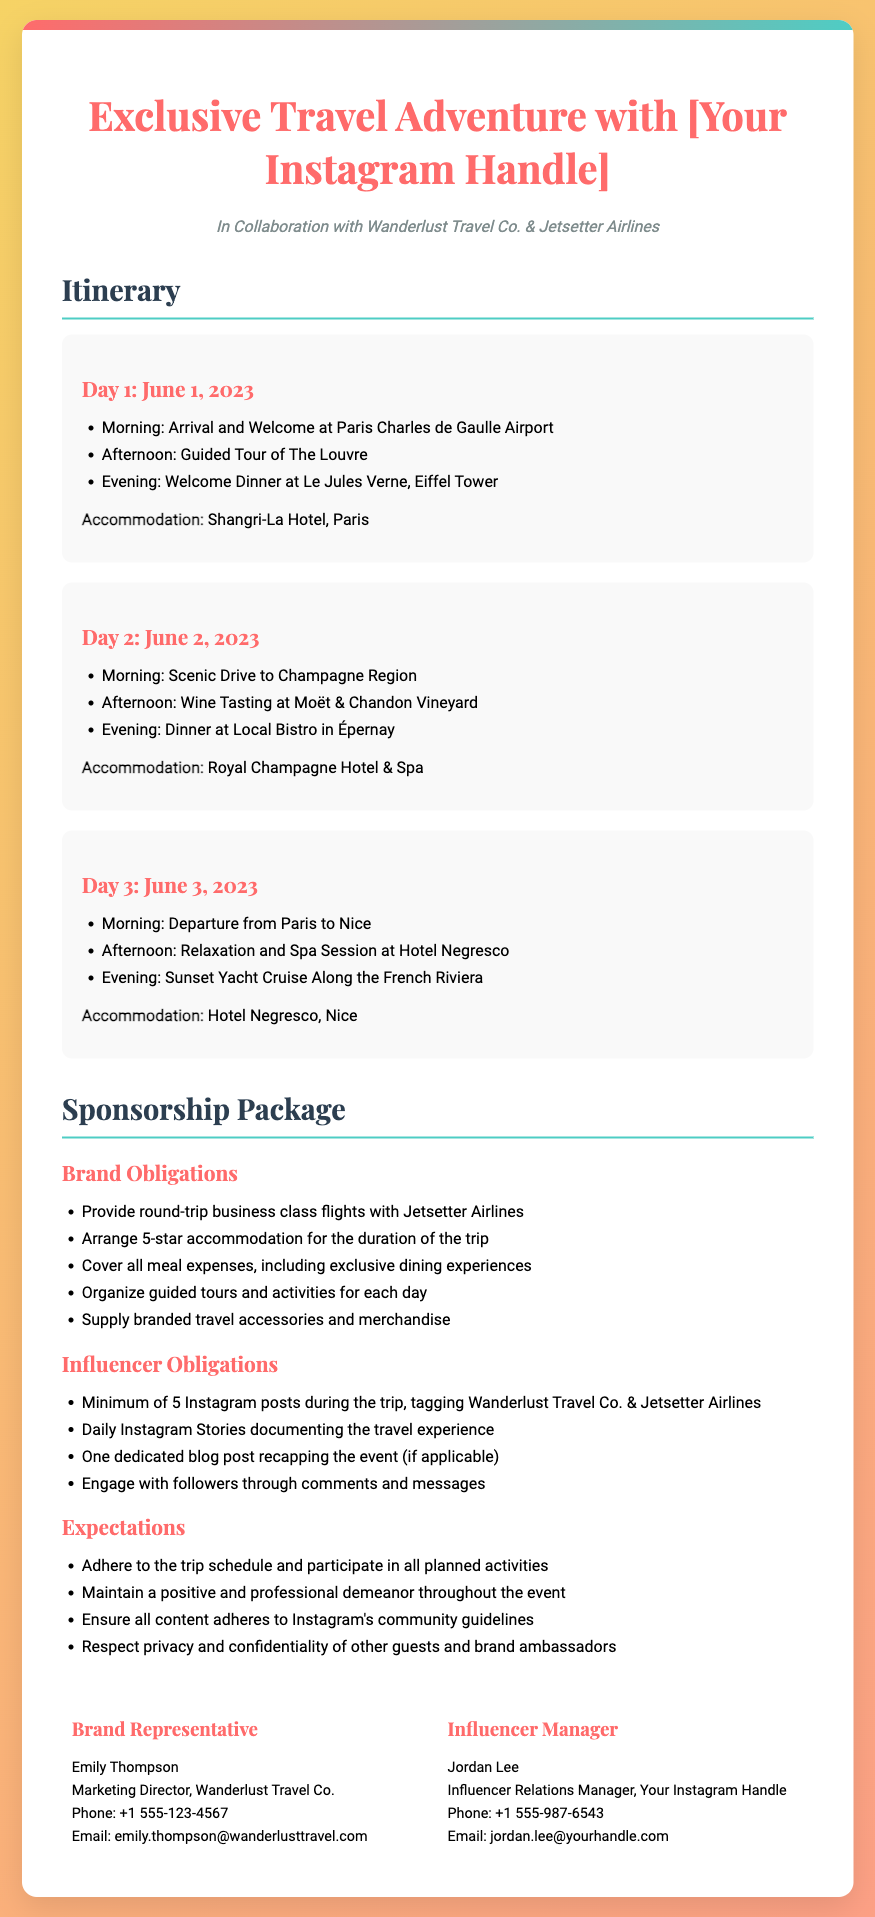What date does the event start? The itinerary mentions Day 1 starts on June 1, 2023.
Answer: June 1, 2023 What is the accommodation for Day 2? The document states that the accommodation for Day 2 is Royal Champagne Hotel & Spa.
Answer: Royal Champagne Hotel & Spa How many Instagram posts are required? The influencer obligations specify a minimum of 5 Instagram posts during the trip.
Answer: 5 What is one of the activities planned for Day 1? The itinerary lists a Guided Tour of The Louvre as one of the activities for Day 1.
Answer: Guided Tour of The Louvre Who is the Marketing Director of Wanderlust Travel Co.? The contact information section provides the name Emily Thompson as the Marketing Director.
Answer: Emily Thompson What is the brand's obligation regarding flights? The document specifies that the brand must provide round-trip business class flights with Jetsetter Airlines.
Answer: Round-trip business class flights What must the influencer maintain during the event? The expectations section indicates that the influencer must maintain a positive and professional demeanor throughout the event.
Answer: Positive and professional demeanor What is included in the expectations for content creation? The expectations mention that all content must adhere to Instagram's community guidelines.
Answer: Adhere to Instagram's community guidelines What is one of the influencer's obligations besides posting? According to the influencer obligations, they must engage with followers through comments and messages.
Answer: Engage with followers through comments and messages 